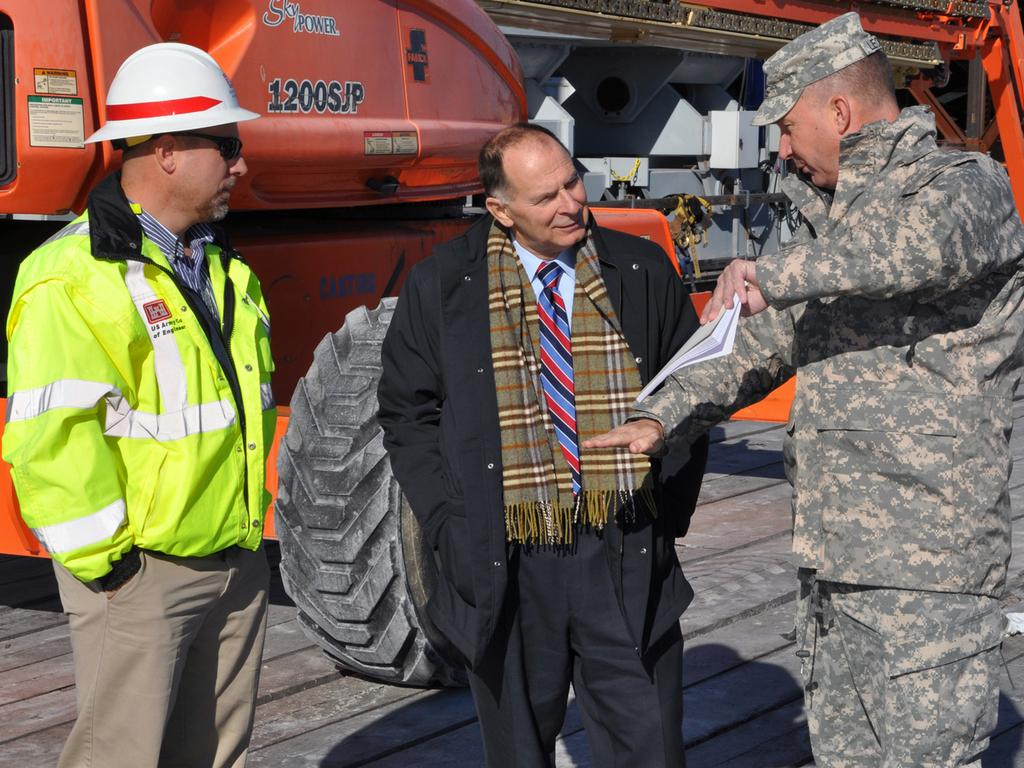How many people are in the image? There are three men in the image. What is one of the men holding? One of the men is holding a book. Can you describe the background of the image? There is a vehicle in the background of the image. How many legs does the pencil have in the image? There is no pencil present in the image, so it is not possible to determine how many legs it might have. 